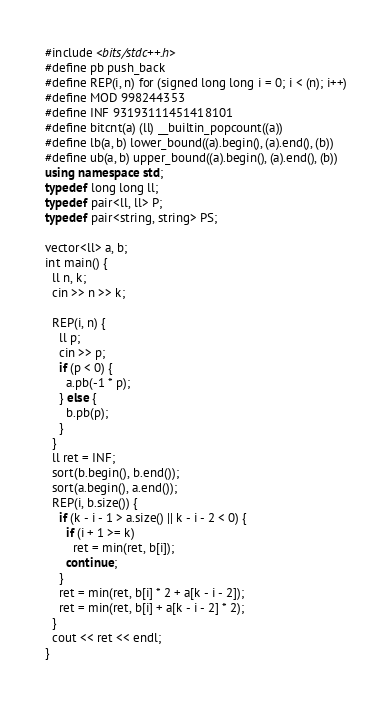<code> <loc_0><loc_0><loc_500><loc_500><_C++_>#include <bits/stdc++.h>
#define pb push_back
#define REP(i, n) for (signed long long i = 0; i < (n); i++)
#define MOD 998244353
#define INF 93193111451418101
#define bitcnt(a) (ll) __builtin_popcount((a))
#define lb(a, b) lower_bound((a).begin(), (a).end(), (b))
#define ub(a, b) upper_bound((a).begin(), (a).end(), (b))
using namespace std;
typedef long long ll;
typedef pair<ll, ll> P;
typedef pair<string, string> PS;

vector<ll> a, b;
int main() {
  ll n, k;
  cin >> n >> k;

  REP(i, n) {
    ll p;
    cin >> p;
    if (p < 0) {
      a.pb(-1 * p);
    } else {
      b.pb(p);
    }
  }
  ll ret = INF;
  sort(b.begin(), b.end());
  sort(a.begin(), a.end());
  REP(i, b.size()) {
    if (k - i - 1 > a.size() || k - i - 2 < 0) {
      if (i + 1 >= k)
        ret = min(ret, b[i]);
      continue;
    }
    ret = min(ret, b[i] * 2 + a[k - i - 2]);
    ret = min(ret, b[i] + a[k - i - 2] * 2);
  }
  cout << ret << endl;
}</code> 